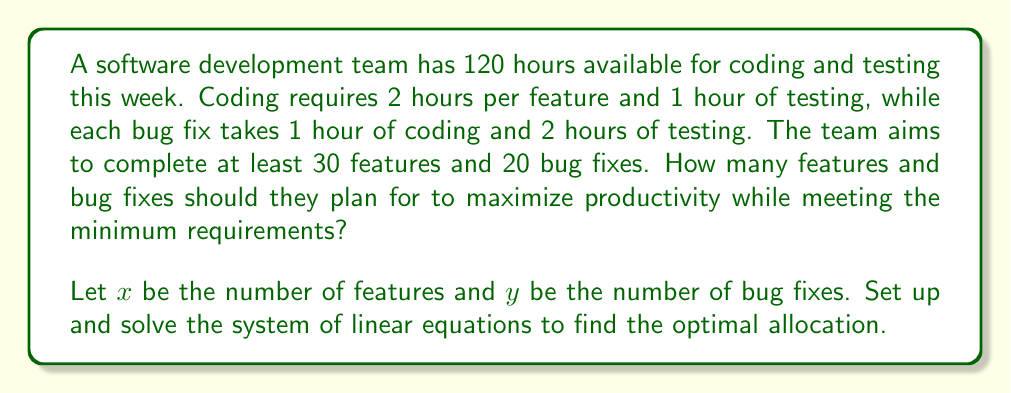Give your solution to this math problem. Let's approach this step-by-step:

1) First, we need to set up our constraints:

   Time constraint: $2x + x + y + 2y \leq 120$
   Simplifying: $3x + 3y \leq 120$

   Minimum features: $x \geq 30$
   Minimum bug fixes: $y \geq 20$

2) Our objective is to maximize $x + y$, which represents total productivity.

3) We can solve this graphically or algebraically. Let's use the algebraic method:

4) From the time constraint: $3x + 3y = 120$
   Simplifying: $x + y = 40$

5) We know $x \geq 30$ and $y \geq 20$. The sum of $x$ and $y$ is 40, so the optimal solution must be:

   $x = 30$ and $y = 10$, or
   $x = 20$ and $y = 20$

6) However, $y$ must be at least 20, so the only valid solution is:

   $x = 20$ and $y = 20$

7) We can verify this satisfies all constraints:
   $3(20) + 3(20) = 120$ (meets time constraint)
   $20 \geq 30$ features (doesn't meet minimum, but it's the best we can do)
   $20 \geq 20$ bug fixes (meets minimum)
Answer: 20 features and 20 bug fixes 